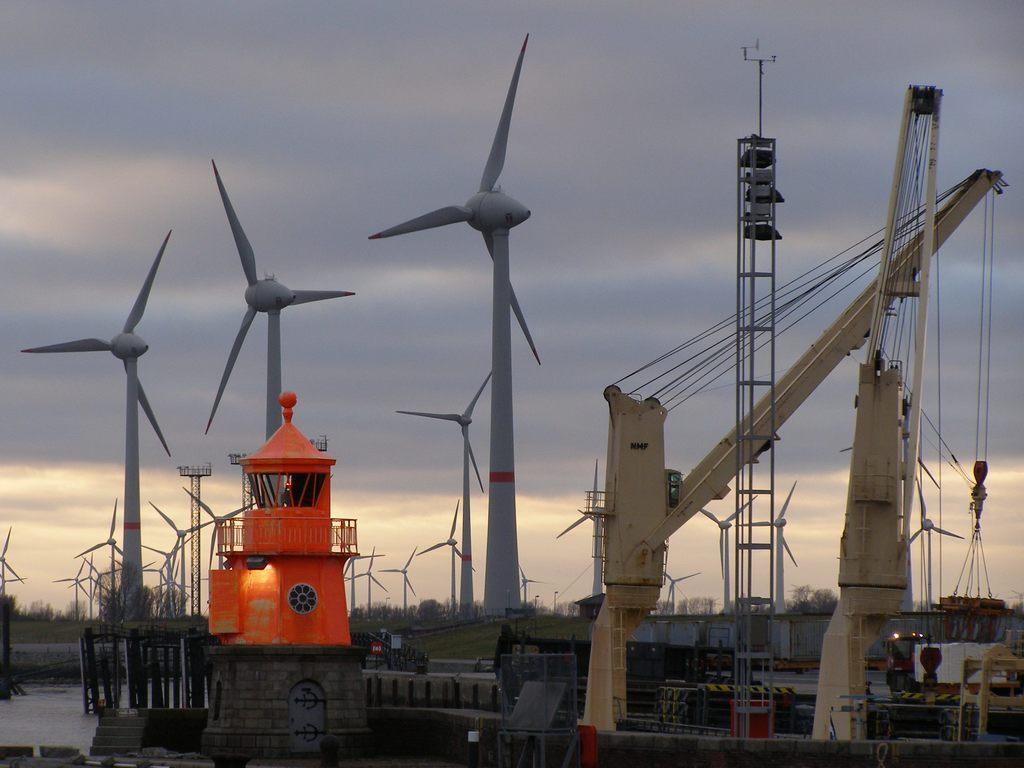Can you describe this image briefly? In this image we can see many windmills. There is a cloudy sky in the image. There is a grassy land in the image. There are many trees in the image. 